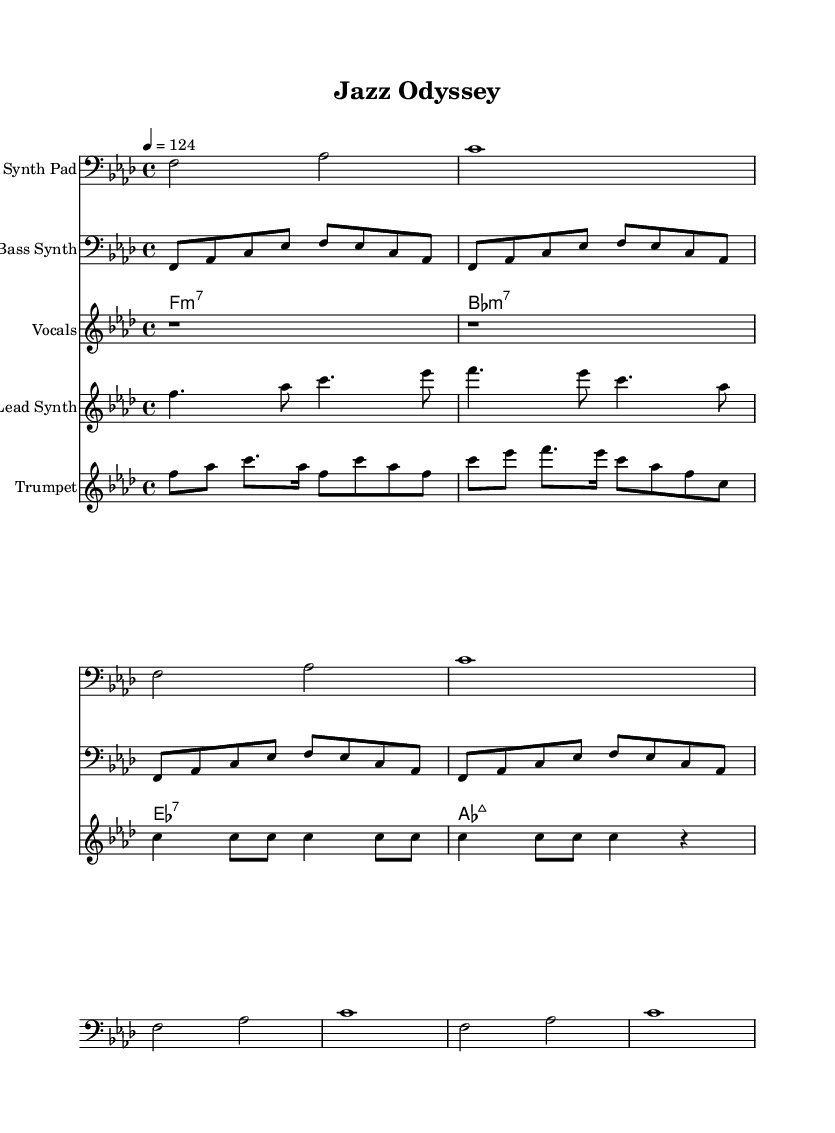What is the key signature of this music? The key signature is F minor, which contains four flats: B♭, E♭, A♭, and D♭. This is determined by examining the key signature provided at the beginning of the score.
Answer: F minor What is the time signature of this piece? The time signature is 4/4, indicating four beats in each measure and a quarter note receives one beat. This information can be found in the notation at the beginning of the score.
Answer: 4/4 What is the tempo marking for the piece? The tempo marking is a quarter note equals 124 beats per minute, which indicates the speed of the piece. The tempo is indicated at the start of the score.
Answer: 124 How many measures are there in the "Vocals" section? The "Vocals" section contains four measures, as indicated by the grouping of horizontal lines (measures) in that specific staff. Each measure is separated visually, allowing for easy counting.
Answer: 4 What type of vocal style is represented in this music? The vocal style here is soulful, characterized by the use of longer note values and expressive rhythms typical in arrangements that sample classic jazz recordings. This can be inferred from the nature of the written vocal line.
Answer: Soulful What instruments are used in this composition? The instruments in this composition include synth pad, bass synth, piano, vocals, lead synth, and trumpet. This is deduced from the separate staves labeled for each instrument at the beginning of the score.
Answer: Synth pad, bass synth, piano, vocals, lead synth, trumpet What is the chord progression in the "Piano Chords" section? The chord progression is F minor 7, B♭ minor 7, E♭ 7, A♭ major 7. These chords are outlined in the chord names section and are a vital part of the harmonic structure in deep house music with jazz influences.
Answer: F minor 7, B♭ minor 7, E♭ 7, A♭ major 7 